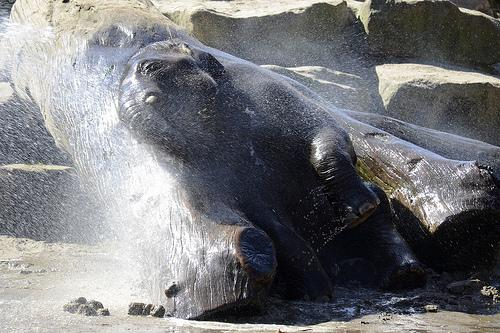In one sentence, describe the main subject's surroundings in the image. The wet elephant is amidst water droplets, a statue in water, wet rocks, and sunlit stones. Describe how the main subject interacts with the water in the image. The wet black elephant playfully leans on the rocks during its shower, as water droplets create a lively scene filled with splashes and beauty. Discuss the relationship between the main subject and its surrounding environment. The wet elephant is leaning on rocks, enjoying a refreshing shower with water droplets being sprayed on and around it, as the sun illuminates the wet environment. Narrate a brief storyline inspired by the image. The black elephant happily leaned on the wet rocks, showering in sweet droplets of life as the sun peeked through the clouds and sparkled on the mysterious figure hidden in the water. Write a brief description of the image focusing on the primary subject and its actions. A large, wet, black elephant is interacting with water, showering itself and creating water droplets on rocks and surrounding elements. Summarize the key components of the image in a succinct manner. Elephant being sprayed with water, leaning on wet rocks, statue in water, water droplets on rocks, and sunshine on grey rocks. Describe the key features of the image in a poetic style. A majestic black elephant bathes amidst glistening water droplets, illuminated by golden sunrays on wet rocks and a statue peeks from the water's embrace. Imagine the main subject's thoughts in the image and describe them. The black elephant relished the refreshing sensation of water on its rugged skin, surrounded by glistening sunlight and protective wet rocks, feeling truly at home and content. Mention the main subject's appearance and the overall context of the image. A big black wet elephant is showering with water droplets on and around it, surrounded by wet rocks illuminated by sunrays. List down the main action the subject is involved in along with the surrounding elements. Wet elephant leaning on rocks, getting sprayed with water, with sunshine on rocks and water droplets all around. 